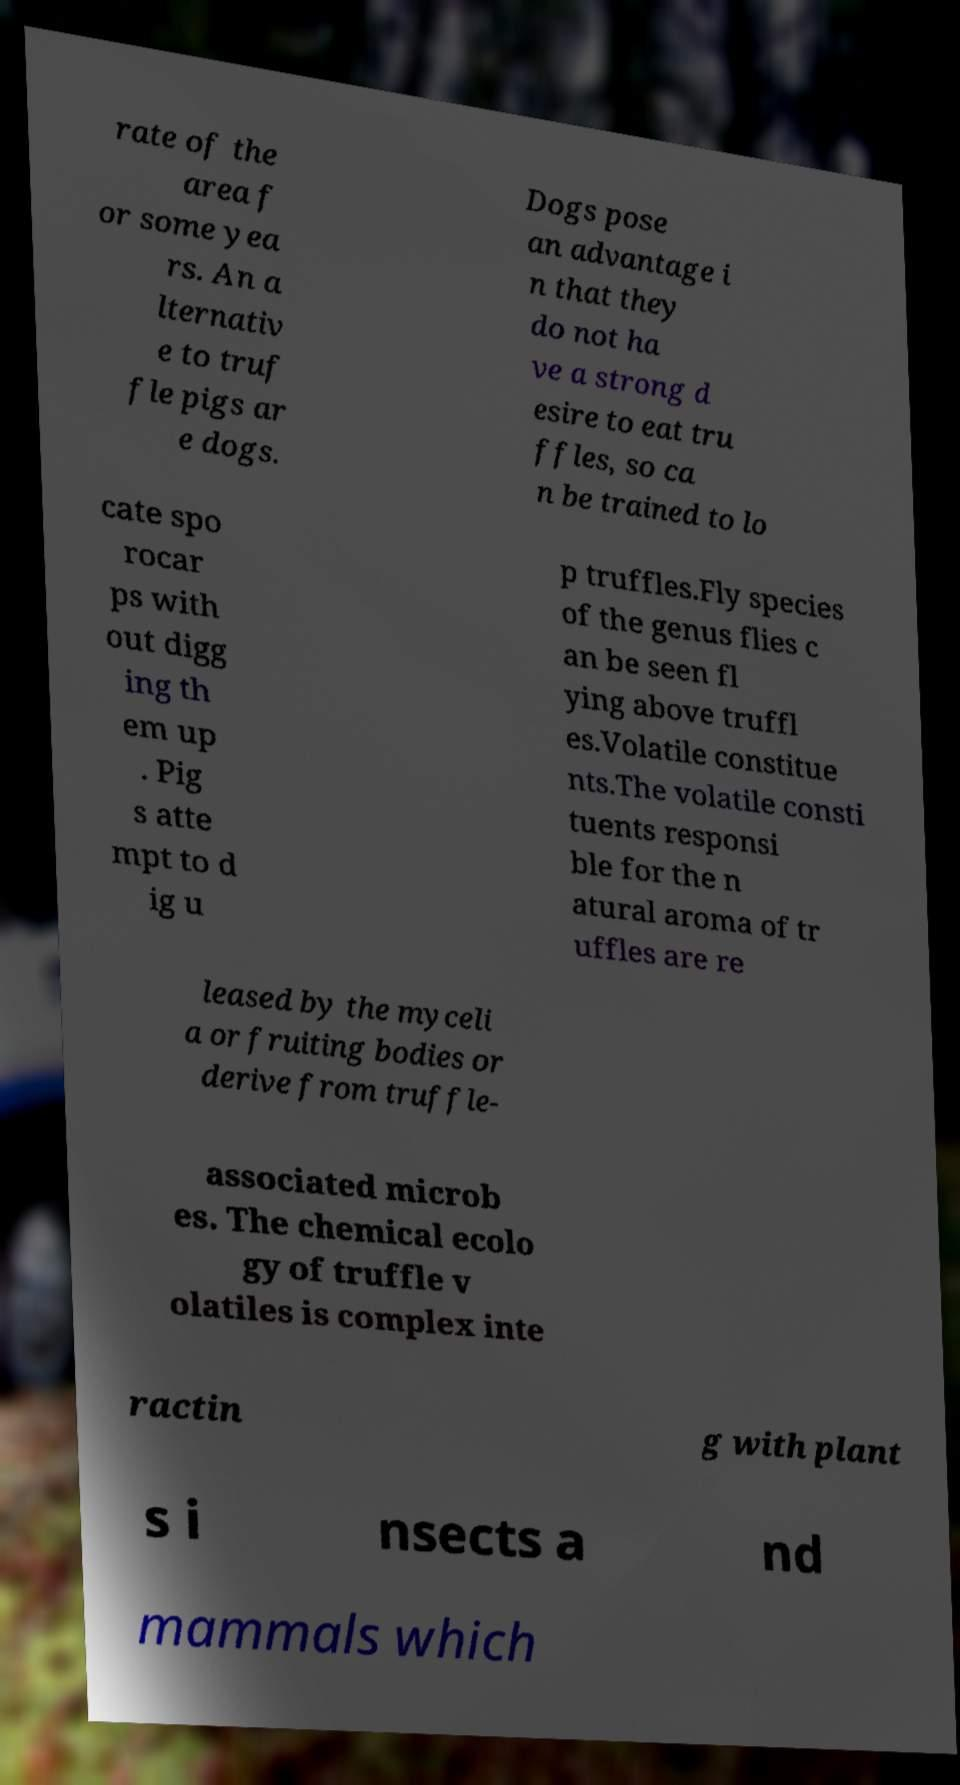Can you accurately transcribe the text from the provided image for me? rate of the area f or some yea rs. An a lternativ e to truf fle pigs ar e dogs. Dogs pose an advantage i n that they do not ha ve a strong d esire to eat tru ffles, so ca n be trained to lo cate spo rocar ps with out digg ing th em up . Pig s atte mpt to d ig u p truffles.Fly species of the genus flies c an be seen fl ying above truffl es.Volatile constitue nts.The volatile consti tuents responsi ble for the n atural aroma of tr uffles are re leased by the myceli a or fruiting bodies or derive from truffle- associated microb es. The chemical ecolo gy of truffle v olatiles is complex inte ractin g with plant s i nsects a nd mammals which 